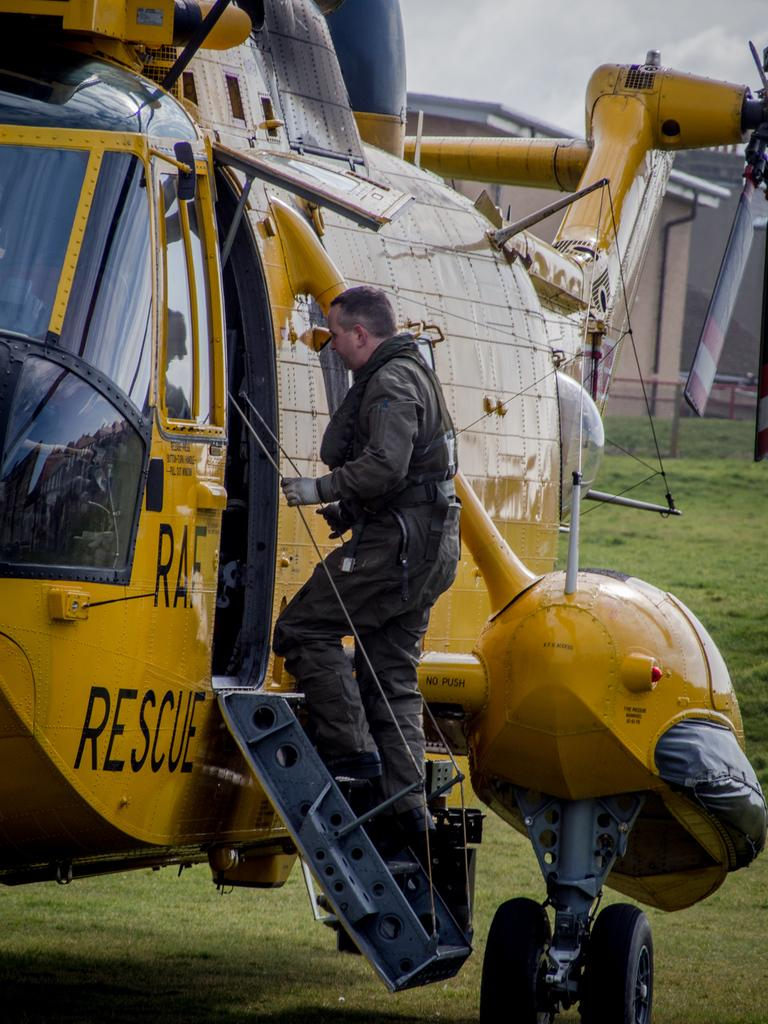Provide a one-sentence caption for the provided image. Man getting on a rescue helicopter about to fly. 